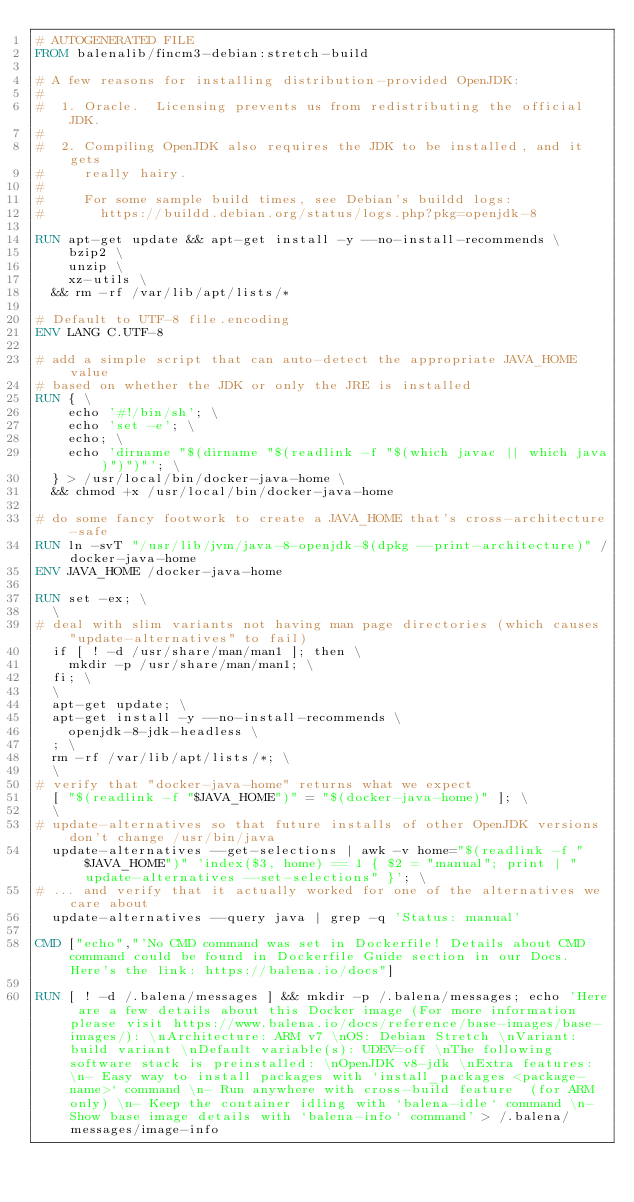<code> <loc_0><loc_0><loc_500><loc_500><_Dockerfile_># AUTOGENERATED FILE
FROM balenalib/fincm3-debian:stretch-build

# A few reasons for installing distribution-provided OpenJDK:
#
#  1. Oracle.  Licensing prevents us from redistributing the official JDK.
#
#  2. Compiling OpenJDK also requires the JDK to be installed, and it gets
#     really hairy.
#
#     For some sample build times, see Debian's buildd logs:
#       https://buildd.debian.org/status/logs.php?pkg=openjdk-8

RUN apt-get update && apt-get install -y --no-install-recommends \
		bzip2 \
		unzip \
		xz-utils \
	&& rm -rf /var/lib/apt/lists/*

# Default to UTF-8 file.encoding
ENV LANG C.UTF-8

# add a simple script that can auto-detect the appropriate JAVA_HOME value
# based on whether the JDK or only the JRE is installed
RUN { \
		echo '#!/bin/sh'; \
		echo 'set -e'; \
		echo; \
		echo 'dirname "$(dirname "$(readlink -f "$(which javac || which java)")")"'; \
	} > /usr/local/bin/docker-java-home \
	&& chmod +x /usr/local/bin/docker-java-home

# do some fancy footwork to create a JAVA_HOME that's cross-architecture-safe
RUN ln -svT "/usr/lib/jvm/java-8-openjdk-$(dpkg --print-architecture)" /docker-java-home
ENV JAVA_HOME /docker-java-home

RUN set -ex; \
	\
# deal with slim variants not having man page directories (which causes "update-alternatives" to fail)
	if [ ! -d /usr/share/man/man1 ]; then \
		mkdir -p /usr/share/man/man1; \
	fi; \
	\
	apt-get update; \
	apt-get install -y --no-install-recommends \
		openjdk-8-jdk-headless \
	; \
	rm -rf /var/lib/apt/lists/*; \
	\
# verify that "docker-java-home" returns what we expect
	[ "$(readlink -f "$JAVA_HOME")" = "$(docker-java-home)" ]; \
	\
# update-alternatives so that future installs of other OpenJDK versions don't change /usr/bin/java
	update-alternatives --get-selections | awk -v home="$(readlink -f "$JAVA_HOME")" 'index($3, home) == 1 { $2 = "manual"; print | "update-alternatives --set-selections" }'; \
# ... and verify that it actually worked for one of the alternatives we care about
	update-alternatives --query java | grep -q 'Status: manual'

CMD ["echo","'No CMD command was set in Dockerfile! Details about CMD command could be found in Dockerfile Guide section in our Docs. Here's the link: https://balena.io/docs"]

RUN [ ! -d /.balena/messages ] && mkdir -p /.balena/messages; echo 'Here are a few details about this Docker image (For more information please visit https://www.balena.io/docs/reference/base-images/base-images/): \nArchitecture: ARM v7 \nOS: Debian Stretch \nVariant: build variant \nDefault variable(s): UDEV=off \nThe following software stack is preinstalled: \nOpenJDK v8-jdk \nExtra features: \n- Easy way to install packages with `install_packages <package-name>` command \n- Run anywhere with cross-build feature  (for ARM only) \n- Keep the container idling with `balena-idle` command \n- Show base image details with `balena-info` command' > /.balena/messages/image-info</code> 